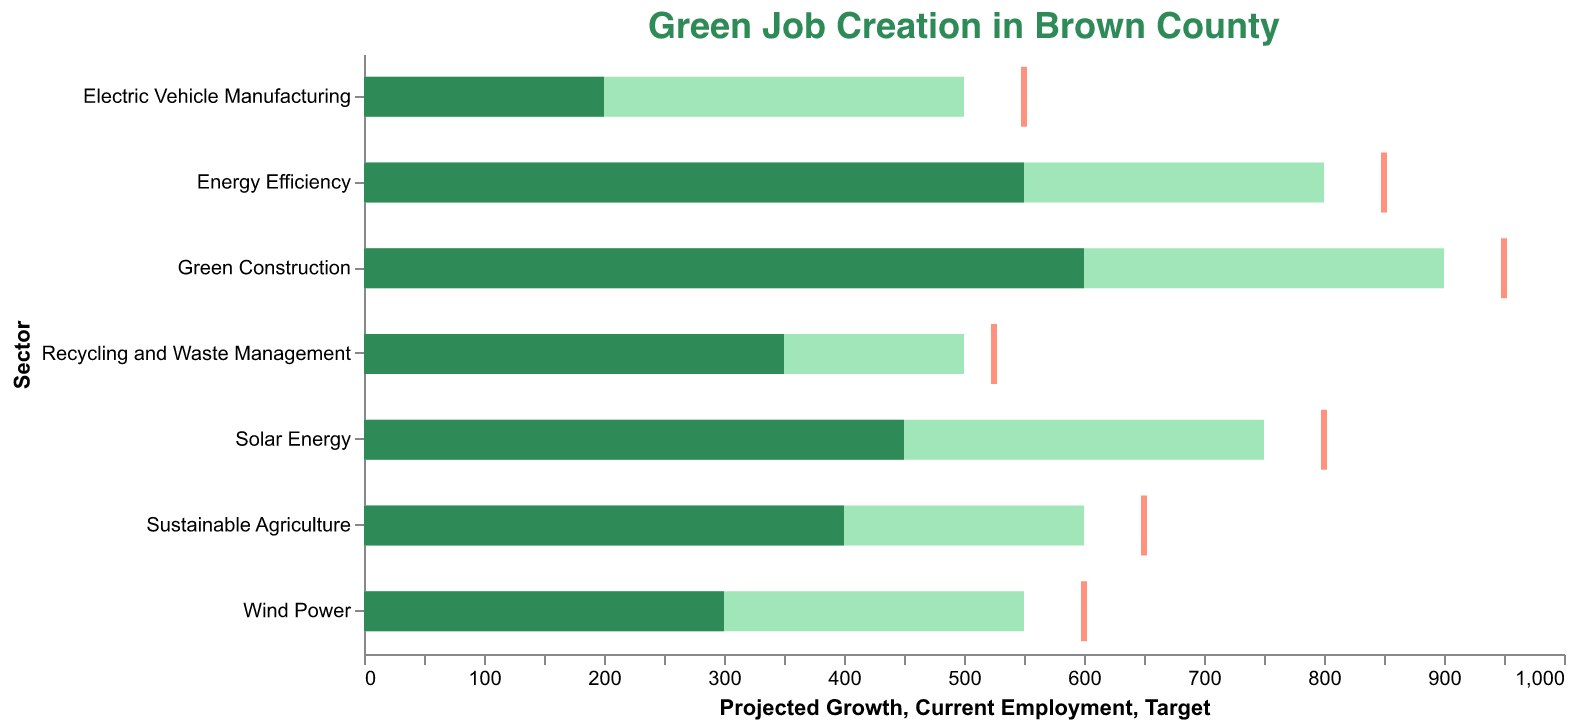How many sustainable sectors are presented in the chart? There are 7 distinct sectors listed in the data: Solar Energy, Wind Power, Energy Efficiency, Sustainable Agriculture, Green Construction, Electric Vehicle Manufacturing, and Recycling and Waste Management.
Answer: 7 What is the projected growth of employment in Solar Energy? The data shows that the projected growth in the Solar Energy sector is 750.
Answer: 750 Which sector has the highest current employment? By comparing the current employment values of all sectors, Green Construction stands out with the highest current employment of 600.
Answer: Green Construction How much more employment is projected in Energy Efficiency compared to Wind Power? The projected employment growth in Energy Efficiency is 800, while for Wind Power, it is 550. The difference is 800 - 550 = 250.
Answer: 250 Is the projected growth in Electric Vehicle Manufacturing higher than its target? The projected growth in Electric Vehicle Manufacturing is 500 and the target is 550. Since 500 is less than 550, the projected growth is not higher than the target.
Answer: No How does the projected growth in Green Construction compare to the target employment in Solar Energy? The projected growth in Green Construction is 900, whereas the target employment in Solar Energy is 800. Comparing these, 900 is greater than 800.
Answer: Greater What is the ratio of current employment in Energy Efficiency to current employment in Wind Power? The current employment in Energy Efficiency is 550, and in Wind Power, it is 300. The ratio is calculated as 550 / 300, which simplifies approximately to 1.83.
Answer: 1.83 